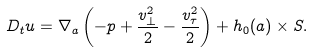Convert formula to latex. <formula><loc_0><loc_0><loc_500><loc_500>D _ { t } { u } = \nabla _ { a } \left ( - p + \frac { v ^ { 2 } _ { \perp } } { 2 } - \frac { v ^ { 2 } _ { \tau } } { 2 } \right ) + { h _ { 0 } ( a ) } \times { S } .</formula> 